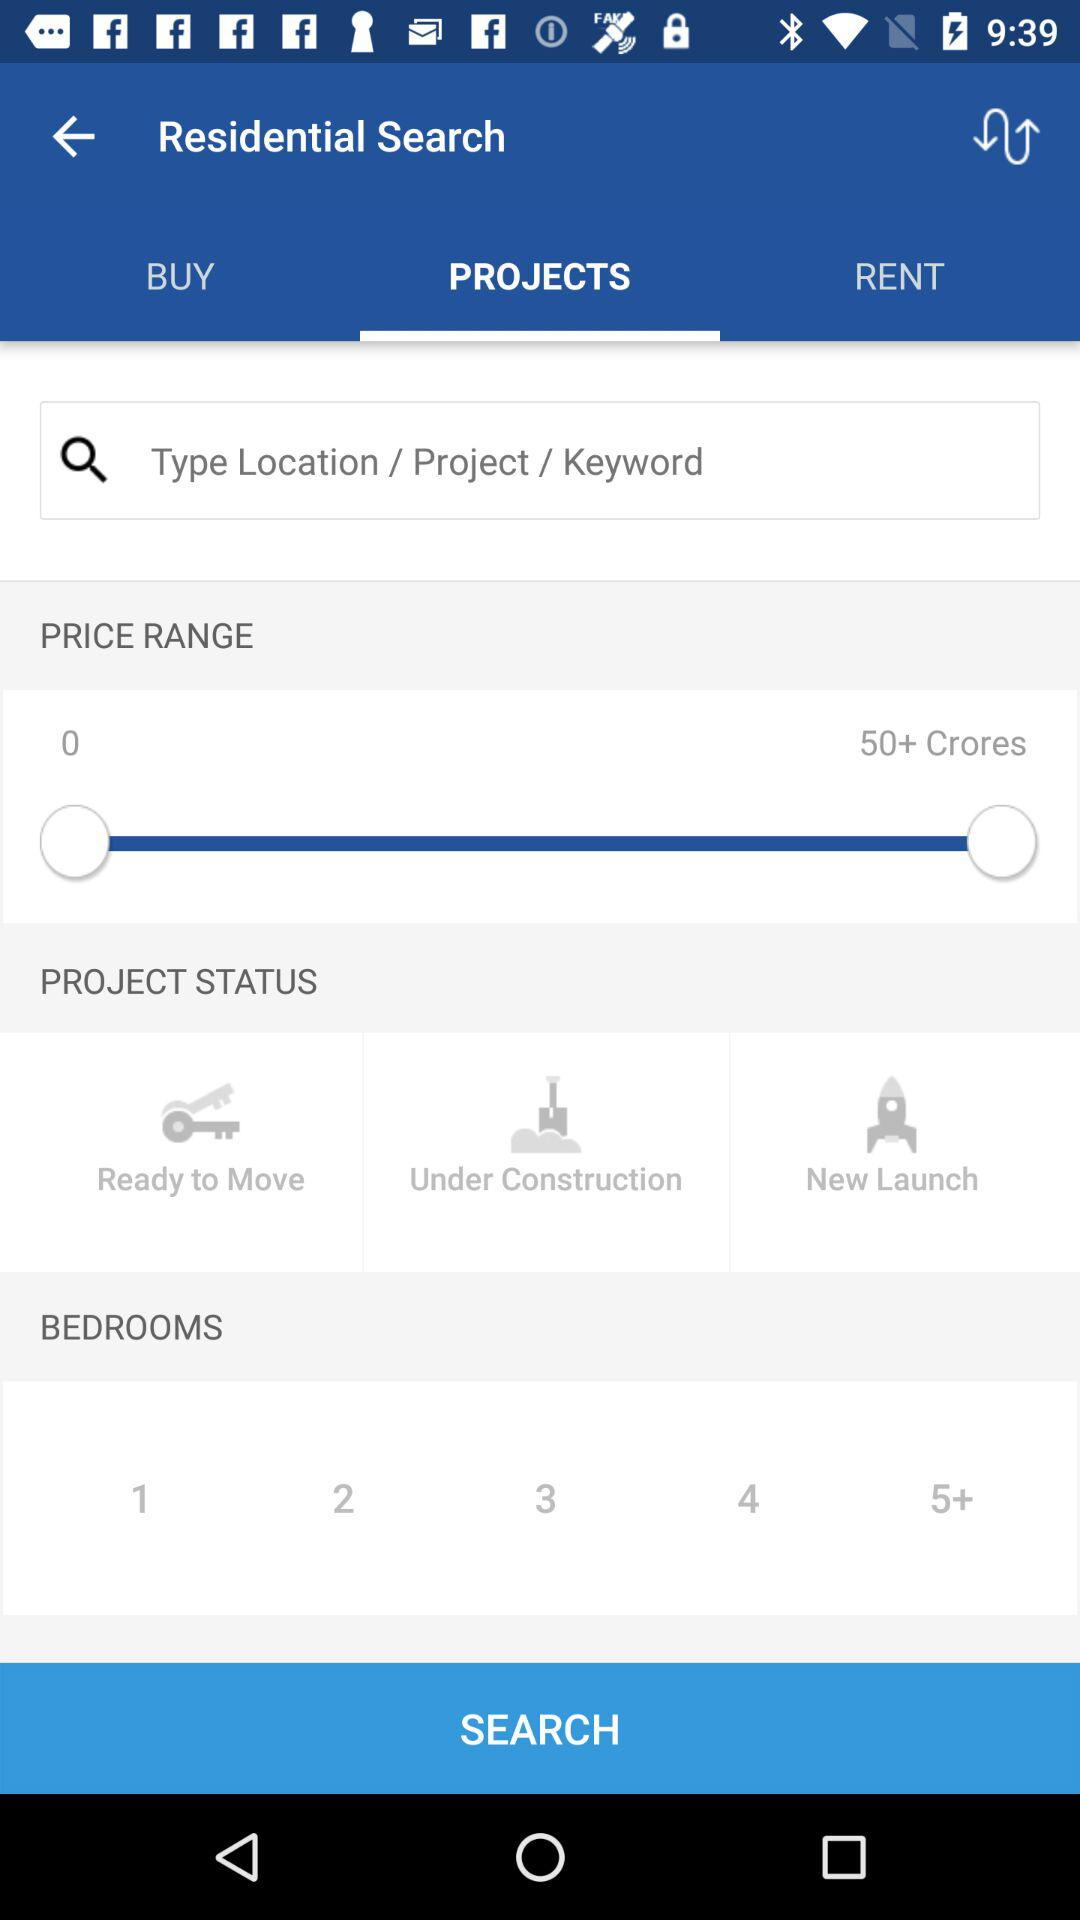How many bedrooms are selected?
When the provided information is insufficient, respond with <no answer>. <no answer> 